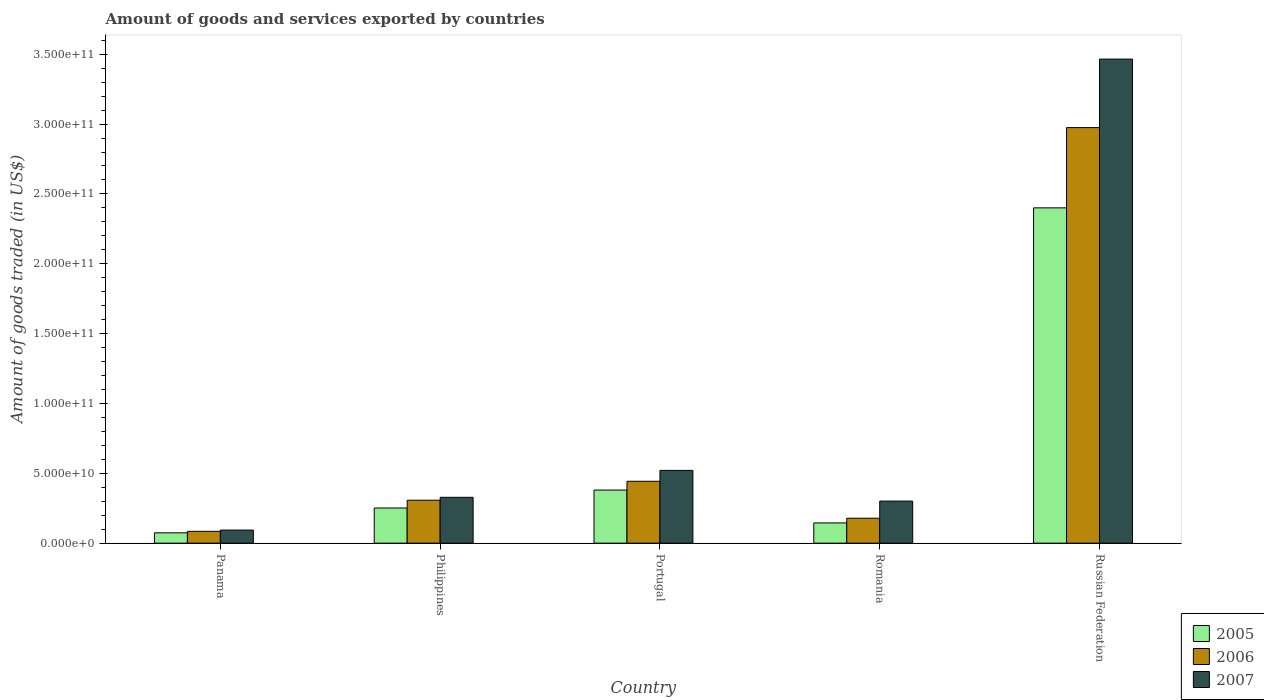Are the number of bars per tick equal to the number of legend labels?
Your answer should be very brief. Yes. How many bars are there on the 5th tick from the left?
Offer a terse response. 3. In how many cases, is the number of bars for a given country not equal to the number of legend labels?
Keep it short and to the point. 0. What is the total amount of goods and services exported in 2006 in Portugal?
Keep it short and to the point. 4.43e+1. Across all countries, what is the maximum total amount of goods and services exported in 2006?
Make the answer very short. 2.97e+11. Across all countries, what is the minimum total amount of goods and services exported in 2007?
Provide a short and direct response. 9.36e+09. In which country was the total amount of goods and services exported in 2005 maximum?
Your answer should be very brief. Russian Federation. In which country was the total amount of goods and services exported in 2006 minimum?
Your answer should be very brief. Panama. What is the total total amount of goods and services exported in 2007 in the graph?
Ensure brevity in your answer.  4.71e+11. What is the difference between the total amount of goods and services exported in 2006 in Panama and that in Philippines?
Offer a terse response. -2.23e+1. What is the difference between the total amount of goods and services exported in 2006 in Portugal and the total amount of goods and services exported in 2007 in Panama?
Offer a terse response. 3.49e+1. What is the average total amount of goods and services exported in 2006 per country?
Your response must be concise. 7.98e+1. What is the difference between the total amount of goods and services exported of/in 2005 and total amount of goods and services exported of/in 2007 in Romania?
Offer a terse response. -1.56e+1. What is the ratio of the total amount of goods and services exported in 2006 in Panama to that in Romania?
Give a very brief answer. 0.47. Is the difference between the total amount of goods and services exported in 2005 in Portugal and Romania greater than the difference between the total amount of goods and services exported in 2007 in Portugal and Romania?
Your answer should be compact. Yes. What is the difference between the highest and the second highest total amount of goods and services exported in 2006?
Your answer should be very brief. 2.67e+11. What is the difference between the highest and the lowest total amount of goods and services exported in 2007?
Your answer should be very brief. 3.37e+11. What does the 2nd bar from the left in Philippines represents?
Your answer should be compact. 2006. What does the 3rd bar from the right in Portugal represents?
Keep it short and to the point. 2005. Are all the bars in the graph horizontal?
Your answer should be very brief. No. What is the difference between two consecutive major ticks on the Y-axis?
Make the answer very short. 5.00e+1. Does the graph contain any zero values?
Ensure brevity in your answer.  No. What is the title of the graph?
Your response must be concise. Amount of goods and services exported by countries. Does "1991" appear as one of the legend labels in the graph?
Provide a short and direct response. No. What is the label or title of the Y-axis?
Give a very brief answer. Amount of goods traded (in US$). What is the Amount of goods traded (in US$) in 2005 in Panama?
Provide a short and direct response. 7.39e+09. What is the Amount of goods traded (in US$) in 2006 in Panama?
Provide a succinct answer. 8.46e+09. What is the Amount of goods traded (in US$) in 2007 in Panama?
Your response must be concise. 9.36e+09. What is the Amount of goods traded (in US$) of 2005 in Philippines?
Give a very brief answer. 2.52e+1. What is the Amount of goods traded (in US$) of 2006 in Philippines?
Your answer should be very brief. 3.07e+1. What is the Amount of goods traded (in US$) in 2007 in Philippines?
Provide a short and direct response. 3.28e+1. What is the Amount of goods traded (in US$) of 2005 in Portugal?
Keep it short and to the point. 3.80e+1. What is the Amount of goods traded (in US$) in 2006 in Portugal?
Your answer should be compact. 4.43e+1. What is the Amount of goods traded (in US$) of 2007 in Portugal?
Your answer should be compact. 5.21e+1. What is the Amount of goods traded (in US$) in 2005 in Romania?
Give a very brief answer. 1.45e+1. What is the Amount of goods traded (in US$) of 2006 in Romania?
Your answer should be compact. 1.78e+1. What is the Amount of goods traded (in US$) of 2007 in Romania?
Keep it short and to the point. 3.01e+1. What is the Amount of goods traded (in US$) of 2005 in Russian Federation?
Your answer should be very brief. 2.40e+11. What is the Amount of goods traded (in US$) in 2006 in Russian Federation?
Keep it short and to the point. 2.97e+11. What is the Amount of goods traded (in US$) of 2007 in Russian Federation?
Provide a succinct answer. 3.47e+11. Across all countries, what is the maximum Amount of goods traded (in US$) of 2005?
Provide a succinct answer. 2.40e+11. Across all countries, what is the maximum Amount of goods traded (in US$) in 2006?
Make the answer very short. 2.97e+11. Across all countries, what is the maximum Amount of goods traded (in US$) of 2007?
Your response must be concise. 3.47e+11. Across all countries, what is the minimum Amount of goods traded (in US$) of 2005?
Keep it short and to the point. 7.39e+09. Across all countries, what is the minimum Amount of goods traded (in US$) of 2006?
Offer a terse response. 8.46e+09. Across all countries, what is the minimum Amount of goods traded (in US$) of 2007?
Offer a terse response. 9.36e+09. What is the total Amount of goods traded (in US$) in 2005 in the graph?
Offer a very short reply. 3.25e+11. What is the total Amount of goods traded (in US$) of 2006 in the graph?
Provide a succinct answer. 3.99e+11. What is the total Amount of goods traded (in US$) in 2007 in the graph?
Make the answer very short. 4.71e+11. What is the difference between the Amount of goods traded (in US$) of 2005 in Panama and that in Philippines?
Ensure brevity in your answer.  -1.78e+1. What is the difference between the Amount of goods traded (in US$) in 2006 in Panama and that in Philippines?
Offer a very short reply. -2.23e+1. What is the difference between the Amount of goods traded (in US$) of 2007 in Panama and that in Philippines?
Provide a short and direct response. -2.34e+1. What is the difference between the Amount of goods traded (in US$) of 2005 in Panama and that in Portugal?
Your answer should be compact. -3.06e+1. What is the difference between the Amount of goods traded (in US$) in 2006 in Panama and that in Portugal?
Offer a terse response. -3.58e+1. What is the difference between the Amount of goods traded (in US$) in 2007 in Panama and that in Portugal?
Offer a terse response. -4.27e+1. What is the difference between the Amount of goods traded (in US$) of 2005 in Panama and that in Romania?
Give a very brief answer. -7.10e+09. What is the difference between the Amount of goods traded (in US$) in 2006 in Panama and that in Romania?
Your response must be concise. -9.38e+09. What is the difference between the Amount of goods traded (in US$) of 2007 in Panama and that in Romania?
Ensure brevity in your answer.  -2.07e+1. What is the difference between the Amount of goods traded (in US$) in 2005 in Panama and that in Russian Federation?
Ensure brevity in your answer.  -2.33e+11. What is the difference between the Amount of goods traded (in US$) in 2006 in Panama and that in Russian Federation?
Give a very brief answer. -2.89e+11. What is the difference between the Amount of goods traded (in US$) of 2007 in Panama and that in Russian Federation?
Keep it short and to the point. -3.37e+11. What is the difference between the Amount of goods traded (in US$) of 2005 in Philippines and that in Portugal?
Provide a short and direct response. -1.29e+1. What is the difference between the Amount of goods traded (in US$) in 2006 in Philippines and that in Portugal?
Your response must be concise. -1.36e+1. What is the difference between the Amount of goods traded (in US$) of 2007 in Philippines and that in Portugal?
Your answer should be compact. -1.93e+1. What is the difference between the Amount of goods traded (in US$) in 2005 in Philippines and that in Romania?
Your answer should be very brief. 1.07e+1. What is the difference between the Amount of goods traded (in US$) of 2006 in Philippines and that in Romania?
Your response must be concise. 1.29e+1. What is the difference between the Amount of goods traded (in US$) in 2007 in Philippines and that in Romania?
Your answer should be compact. 2.70e+09. What is the difference between the Amount of goods traded (in US$) of 2005 in Philippines and that in Russian Federation?
Provide a succinct answer. -2.15e+11. What is the difference between the Amount of goods traded (in US$) in 2006 in Philippines and that in Russian Federation?
Your answer should be compact. -2.67e+11. What is the difference between the Amount of goods traded (in US$) of 2007 in Philippines and that in Russian Federation?
Keep it short and to the point. -3.14e+11. What is the difference between the Amount of goods traded (in US$) in 2005 in Portugal and that in Romania?
Provide a succinct answer. 2.35e+1. What is the difference between the Amount of goods traded (in US$) in 2006 in Portugal and that in Romania?
Give a very brief answer. 2.65e+1. What is the difference between the Amount of goods traded (in US$) in 2007 in Portugal and that in Romania?
Ensure brevity in your answer.  2.20e+1. What is the difference between the Amount of goods traded (in US$) of 2005 in Portugal and that in Russian Federation?
Your answer should be compact. -2.02e+11. What is the difference between the Amount of goods traded (in US$) in 2006 in Portugal and that in Russian Federation?
Your answer should be compact. -2.53e+11. What is the difference between the Amount of goods traded (in US$) of 2007 in Portugal and that in Russian Federation?
Your answer should be very brief. -2.94e+11. What is the difference between the Amount of goods traded (in US$) of 2005 in Romania and that in Russian Federation?
Give a very brief answer. -2.26e+11. What is the difference between the Amount of goods traded (in US$) of 2006 in Romania and that in Russian Federation?
Your answer should be compact. -2.80e+11. What is the difference between the Amount of goods traded (in US$) in 2007 in Romania and that in Russian Federation?
Keep it short and to the point. -3.16e+11. What is the difference between the Amount of goods traded (in US$) in 2005 in Panama and the Amount of goods traded (in US$) in 2006 in Philippines?
Provide a succinct answer. -2.33e+1. What is the difference between the Amount of goods traded (in US$) in 2005 in Panama and the Amount of goods traded (in US$) in 2007 in Philippines?
Offer a very short reply. -2.54e+1. What is the difference between the Amount of goods traded (in US$) in 2006 in Panama and the Amount of goods traded (in US$) in 2007 in Philippines?
Your response must be concise. -2.43e+1. What is the difference between the Amount of goods traded (in US$) in 2005 in Panama and the Amount of goods traded (in US$) in 2006 in Portugal?
Your answer should be compact. -3.69e+1. What is the difference between the Amount of goods traded (in US$) in 2005 in Panama and the Amount of goods traded (in US$) in 2007 in Portugal?
Make the answer very short. -4.47e+1. What is the difference between the Amount of goods traded (in US$) of 2006 in Panama and the Amount of goods traded (in US$) of 2007 in Portugal?
Your response must be concise. -4.36e+1. What is the difference between the Amount of goods traded (in US$) in 2005 in Panama and the Amount of goods traded (in US$) in 2006 in Romania?
Your response must be concise. -1.05e+1. What is the difference between the Amount of goods traded (in US$) of 2005 in Panama and the Amount of goods traded (in US$) of 2007 in Romania?
Make the answer very short. -2.27e+1. What is the difference between the Amount of goods traded (in US$) of 2006 in Panama and the Amount of goods traded (in US$) of 2007 in Romania?
Your answer should be compact. -2.16e+1. What is the difference between the Amount of goods traded (in US$) in 2005 in Panama and the Amount of goods traded (in US$) in 2006 in Russian Federation?
Offer a terse response. -2.90e+11. What is the difference between the Amount of goods traded (in US$) of 2005 in Panama and the Amount of goods traded (in US$) of 2007 in Russian Federation?
Keep it short and to the point. -3.39e+11. What is the difference between the Amount of goods traded (in US$) of 2006 in Panama and the Amount of goods traded (in US$) of 2007 in Russian Federation?
Offer a terse response. -3.38e+11. What is the difference between the Amount of goods traded (in US$) of 2005 in Philippines and the Amount of goods traded (in US$) of 2006 in Portugal?
Make the answer very short. -1.91e+1. What is the difference between the Amount of goods traded (in US$) in 2005 in Philippines and the Amount of goods traded (in US$) in 2007 in Portugal?
Provide a succinct answer. -2.69e+1. What is the difference between the Amount of goods traded (in US$) in 2006 in Philippines and the Amount of goods traded (in US$) in 2007 in Portugal?
Keep it short and to the point. -2.14e+1. What is the difference between the Amount of goods traded (in US$) in 2005 in Philippines and the Amount of goods traded (in US$) in 2006 in Romania?
Offer a very short reply. 7.32e+09. What is the difference between the Amount of goods traded (in US$) of 2005 in Philippines and the Amount of goods traded (in US$) of 2007 in Romania?
Provide a short and direct response. -4.94e+09. What is the difference between the Amount of goods traded (in US$) of 2006 in Philippines and the Amount of goods traded (in US$) of 2007 in Romania?
Ensure brevity in your answer.  6.36e+08. What is the difference between the Amount of goods traded (in US$) of 2005 in Philippines and the Amount of goods traded (in US$) of 2006 in Russian Federation?
Offer a terse response. -2.72e+11. What is the difference between the Amount of goods traded (in US$) in 2005 in Philippines and the Amount of goods traded (in US$) in 2007 in Russian Federation?
Ensure brevity in your answer.  -3.21e+11. What is the difference between the Amount of goods traded (in US$) of 2006 in Philippines and the Amount of goods traded (in US$) of 2007 in Russian Federation?
Provide a succinct answer. -3.16e+11. What is the difference between the Amount of goods traded (in US$) in 2005 in Portugal and the Amount of goods traded (in US$) in 2006 in Romania?
Give a very brief answer. 2.02e+1. What is the difference between the Amount of goods traded (in US$) of 2005 in Portugal and the Amount of goods traded (in US$) of 2007 in Romania?
Offer a very short reply. 7.92e+09. What is the difference between the Amount of goods traded (in US$) in 2006 in Portugal and the Amount of goods traded (in US$) in 2007 in Romania?
Offer a very short reply. 1.42e+1. What is the difference between the Amount of goods traded (in US$) in 2005 in Portugal and the Amount of goods traded (in US$) in 2006 in Russian Federation?
Your answer should be compact. -2.59e+11. What is the difference between the Amount of goods traded (in US$) in 2005 in Portugal and the Amount of goods traded (in US$) in 2007 in Russian Federation?
Provide a succinct answer. -3.09e+11. What is the difference between the Amount of goods traded (in US$) in 2006 in Portugal and the Amount of goods traded (in US$) in 2007 in Russian Federation?
Your response must be concise. -3.02e+11. What is the difference between the Amount of goods traded (in US$) of 2005 in Romania and the Amount of goods traded (in US$) of 2006 in Russian Federation?
Keep it short and to the point. -2.83e+11. What is the difference between the Amount of goods traded (in US$) of 2005 in Romania and the Amount of goods traded (in US$) of 2007 in Russian Federation?
Your response must be concise. -3.32e+11. What is the difference between the Amount of goods traded (in US$) in 2006 in Romania and the Amount of goods traded (in US$) in 2007 in Russian Federation?
Offer a terse response. -3.29e+11. What is the average Amount of goods traded (in US$) of 2005 per country?
Give a very brief answer. 6.50e+1. What is the average Amount of goods traded (in US$) in 2006 per country?
Your answer should be very brief. 7.98e+1. What is the average Amount of goods traded (in US$) in 2007 per country?
Ensure brevity in your answer.  9.42e+1. What is the difference between the Amount of goods traded (in US$) in 2005 and Amount of goods traded (in US$) in 2006 in Panama?
Offer a terse response. -1.08e+09. What is the difference between the Amount of goods traded (in US$) in 2005 and Amount of goods traded (in US$) in 2007 in Panama?
Give a very brief answer. -1.97e+09. What is the difference between the Amount of goods traded (in US$) in 2006 and Amount of goods traded (in US$) in 2007 in Panama?
Make the answer very short. -8.94e+08. What is the difference between the Amount of goods traded (in US$) in 2005 and Amount of goods traded (in US$) in 2006 in Philippines?
Offer a terse response. -5.57e+09. What is the difference between the Amount of goods traded (in US$) of 2005 and Amount of goods traded (in US$) of 2007 in Philippines?
Your answer should be compact. -7.64e+09. What is the difference between the Amount of goods traded (in US$) in 2006 and Amount of goods traded (in US$) in 2007 in Philippines?
Make the answer very short. -2.07e+09. What is the difference between the Amount of goods traded (in US$) in 2005 and Amount of goods traded (in US$) in 2006 in Portugal?
Offer a terse response. -6.27e+09. What is the difference between the Amount of goods traded (in US$) of 2005 and Amount of goods traded (in US$) of 2007 in Portugal?
Make the answer very short. -1.41e+1. What is the difference between the Amount of goods traded (in US$) of 2006 and Amount of goods traded (in US$) of 2007 in Portugal?
Provide a succinct answer. -7.79e+09. What is the difference between the Amount of goods traded (in US$) in 2005 and Amount of goods traded (in US$) in 2006 in Romania?
Your response must be concise. -3.36e+09. What is the difference between the Amount of goods traded (in US$) of 2005 and Amount of goods traded (in US$) of 2007 in Romania?
Make the answer very short. -1.56e+1. What is the difference between the Amount of goods traded (in US$) in 2006 and Amount of goods traded (in US$) in 2007 in Romania?
Your answer should be compact. -1.23e+1. What is the difference between the Amount of goods traded (in US$) in 2005 and Amount of goods traded (in US$) in 2006 in Russian Federation?
Your response must be concise. -5.75e+1. What is the difference between the Amount of goods traded (in US$) of 2005 and Amount of goods traded (in US$) of 2007 in Russian Federation?
Offer a terse response. -1.07e+11. What is the difference between the Amount of goods traded (in US$) of 2006 and Amount of goods traded (in US$) of 2007 in Russian Federation?
Keep it short and to the point. -4.90e+1. What is the ratio of the Amount of goods traded (in US$) of 2005 in Panama to that in Philippines?
Give a very brief answer. 0.29. What is the ratio of the Amount of goods traded (in US$) of 2006 in Panama to that in Philippines?
Your answer should be compact. 0.28. What is the ratio of the Amount of goods traded (in US$) in 2007 in Panama to that in Philippines?
Offer a terse response. 0.29. What is the ratio of the Amount of goods traded (in US$) in 2005 in Panama to that in Portugal?
Offer a very short reply. 0.19. What is the ratio of the Amount of goods traded (in US$) in 2006 in Panama to that in Portugal?
Ensure brevity in your answer.  0.19. What is the ratio of the Amount of goods traded (in US$) in 2007 in Panama to that in Portugal?
Ensure brevity in your answer.  0.18. What is the ratio of the Amount of goods traded (in US$) in 2005 in Panama to that in Romania?
Ensure brevity in your answer.  0.51. What is the ratio of the Amount of goods traded (in US$) of 2006 in Panama to that in Romania?
Your answer should be very brief. 0.47. What is the ratio of the Amount of goods traded (in US$) of 2007 in Panama to that in Romania?
Your answer should be compact. 0.31. What is the ratio of the Amount of goods traded (in US$) of 2005 in Panama to that in Russian Federation?
Give a very brief answer. 0.03. What is the ratio of the Amount of goods traded (in US$) in 2006 in Panama to that in Russian Federation?
Make the answer very short. 0.03. What is the ratio of the Amount of goods traded (in US$) of 2007 in Panama to that in Russian Federation?
Offer a terse response. 0.03. What is the ratio of the Amount of goods traded (in US$) in 2005 in Philippines to that in Portugal?
Offer a very short reply. 0.66. What is the ratio of the Amount of goods traded (in US$) in 2006 in Philippines to that in Portugal?
Give a very brief answer. 0.69. What is the ratio of the Amount of goods traded (in US$) in 2007 in Philippines to that in Portugal?
Provide a succinct answer. 0.63. What is the ratio of the Amount of goods traded (in US$) of 2005 in Philippines to that in Romania?
Provide a succinct answer. 1.74. What is the ratio of the Amount of goods traded (in US$) of 2006 in Philippines to that in Romania?
Provide a succinct answer. 1.72. What is the ratio of the Amount of goods traded (in US$) in 2007 in Philippines to that in Romania?
Your answer should be compact. 1.09. What is the ratio of the Amount of goods traded (in US$) in 2005 in Philippines to that in Russian Federation?
Make the answer very short. 0.1. What is the ratio of the Amount of goods traded (in US$) of 2006 in Philippines to that in Russian Federation?
Your answer should be compact. 0.1. What is the ratio of the Amount of goods traded (in US$) of 2007 in Philippines to that in Russian Federation?
Make the answer very short. 0.09. What is the ratio of the Amount of goods traded (in US$) in 2005 in Portugal to that in Romania?
Provide a short and direct response. 2.62. What is the ratio of the Amount of goods traded (in US$) in 2006 in Portugal to that in Romania?
Give a very brief answer. 2.48. What is the ratio of the Amount of goods traded (in US$) in 2007 in Portugal to that in Romania?
Provide a short and direct response. 1.73. What is the ratio of the Amount of goods traded (in US$) of 2005 in Portugal to that in Russian Federation?
Your response must be concise. 0.16. What is the ratio of the Amount of goods traded (in US$) in 2006 in Portugal to that in Russian Federation?
Make the answer very short. 0.15. What is the ratio of the Amount of goods traded (in US$) in 2007 in Portugal to that in Russian Federation?
Provide a short and direct response. 0.15. What is the ratio of the Amount of goods traded (in US$) of 2005 in Romania to that in Russian Federation?
Your response must be concise. 0.06. What is the ratio of the Amount of goods traded (in US$) of 2007 in Romania to that in Russian Federation?
Provide a short and direct response. 0.09. What is the difference between the highest and the second highest Amount of goods traded (in US$) in 2005?
Keep it short and to the point. 2.02e+11. What is the difference between the highest and the second highest Amount of goods traded (in US$) in 2006?
Your response must be concise. 2.53e+11. What is the difference between the highest and the second highest Amount of goods traded (in US$) of 2007?
Keep it short and to the point. 2.94e+11. What is the difference between the highest and the lowest Amount of goods traded (in US$) in 2005?
Provide a succinct answer. 2.33e+11. What is the difference between the highest and the lowest Amount of goods traded (in US$) in 2006?
Your response must be concise. 2.89e+11. What is the difference between the highest and the lowest Amount of goods traded (in US$) of 2007?
Keep it short and to the point. 3.37e+11. 